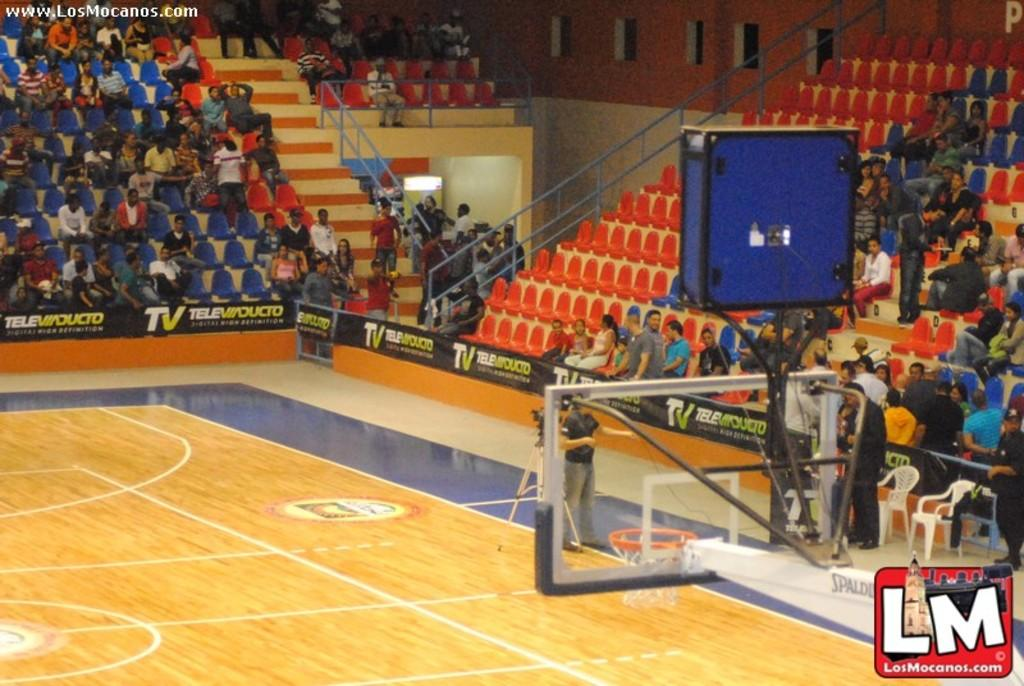<image>
Share a concise interpretation of the image provided. Footage from the basketball court is brought to you by www.LosMocanos.com 